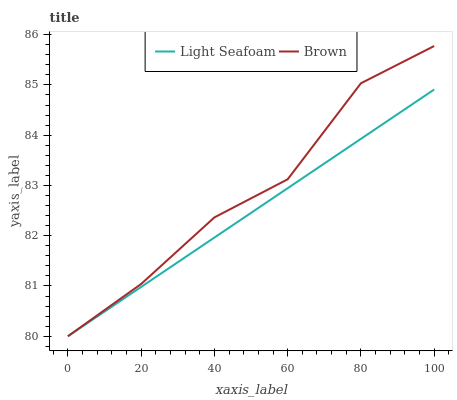Does Light Seafoam have the minimum area under the curve?
Answer yes or no. Yes. Does Brown have the maximum area under the curve?
Answer yes or no. Yes. Does Light Seafoam have the maximum area under the curve?
Answer yes or no. No. Is Light Seafoam the smoothest?
Answer yes or no. Yes. Is Brown the roughest?
Answer yes or no. Yes. Is Light Seafoam the roughest?
Answer yes or no. No. Does Brown have the highest value?
Answer yes or no. Yes. Does Light Seafoam have the highest value?
Answer yes or no. No. Does Light Seafoam intersect Brown?
Answer yes or no. Yes. Is Light Seafoam less than Brown?
Answer yes or no. No. Is Light Seafoam greater than Brown?
Answer yes or no. No. 